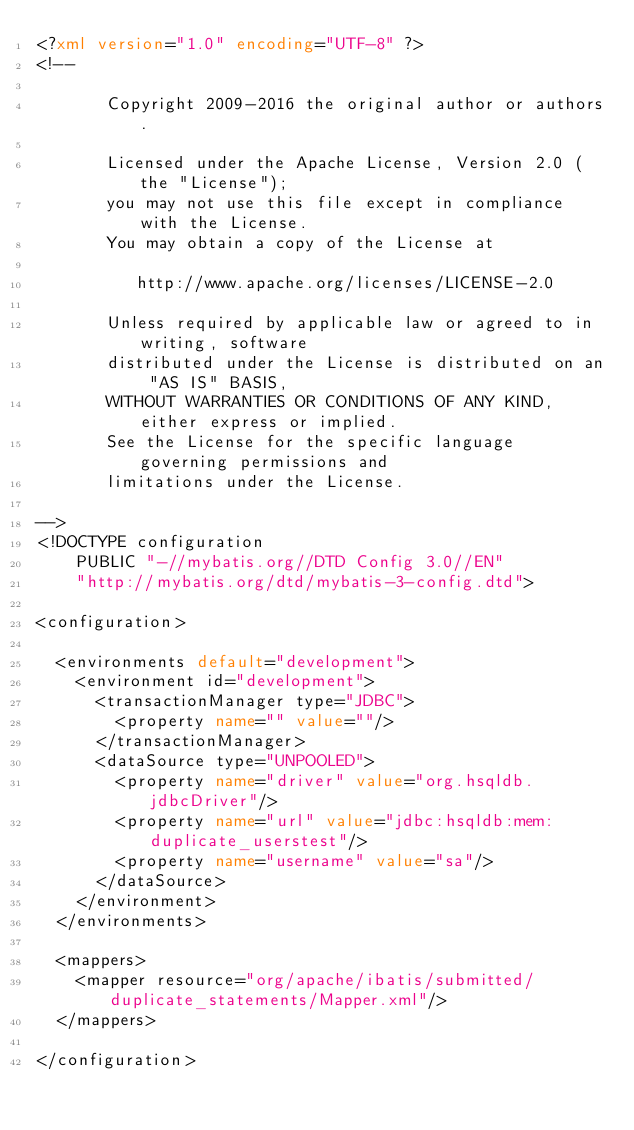Convert code to text. <code><loc_0><loc_0><loc_500><loc_500><_XML_><?xml version="1.0" encoding="UTF-8" ?>
<!--

       Copyright 2009-2016 the original author or authors.

       Licensed under the Apache License, Version 2.0 (the "License");
       you may not use this file except in compliance with the License.
       You may obtain a copy of the License at

          http://www.apache.org/licenses/LICENSE-2.0

       Unless required by applicable law or agreed to in writing, software
       distributed under the License is distributed on an "AS IS" BASIS,
       WITHOUT WARRANTIES OR CONDITIONS OF ANY KIND, either express or implied.
       See the License for the specific language governing permissions and
       limitations under the License.

-->
<!DOCTYPE configuration
    PUBLIC "-//mybatis.org//DTD Config 3.0//EN"
    "http://mybatis.org/dtd/mybatis-3-config.dtd">

<configuration>

  <environments default="development">
    <environment id="development">
      <transactionManager type="JDBC">
        <property name="" value=""/>
      </transactionManager>
      <dataSource type="UNPOOLED">
        <property name="driver" value="org.hsqldb.jdbcDriver"/>
        <property name="url" value="jdbc:hsqldb:mem:duplicate_userstest"/>
        <property name="username" value="sa"/>
      </dataSource>
    </environment>
  </environments>

  <mappers>
    <mapper resource="org/apache/ibatis/submitted/duplicate_statements/Mapper.xml"/>
  </mappers>

</configuration>
</code> 